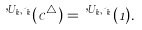<formula> <loc_0><loc_0><loc_500><loc_500>\varphi ^ { U _ { k } , \psi _ { k } } ( c ^ { \triangle } ) = \varphi ^ { U _ { k } , \psi _ { k } } ( 1 ) .</formula> 